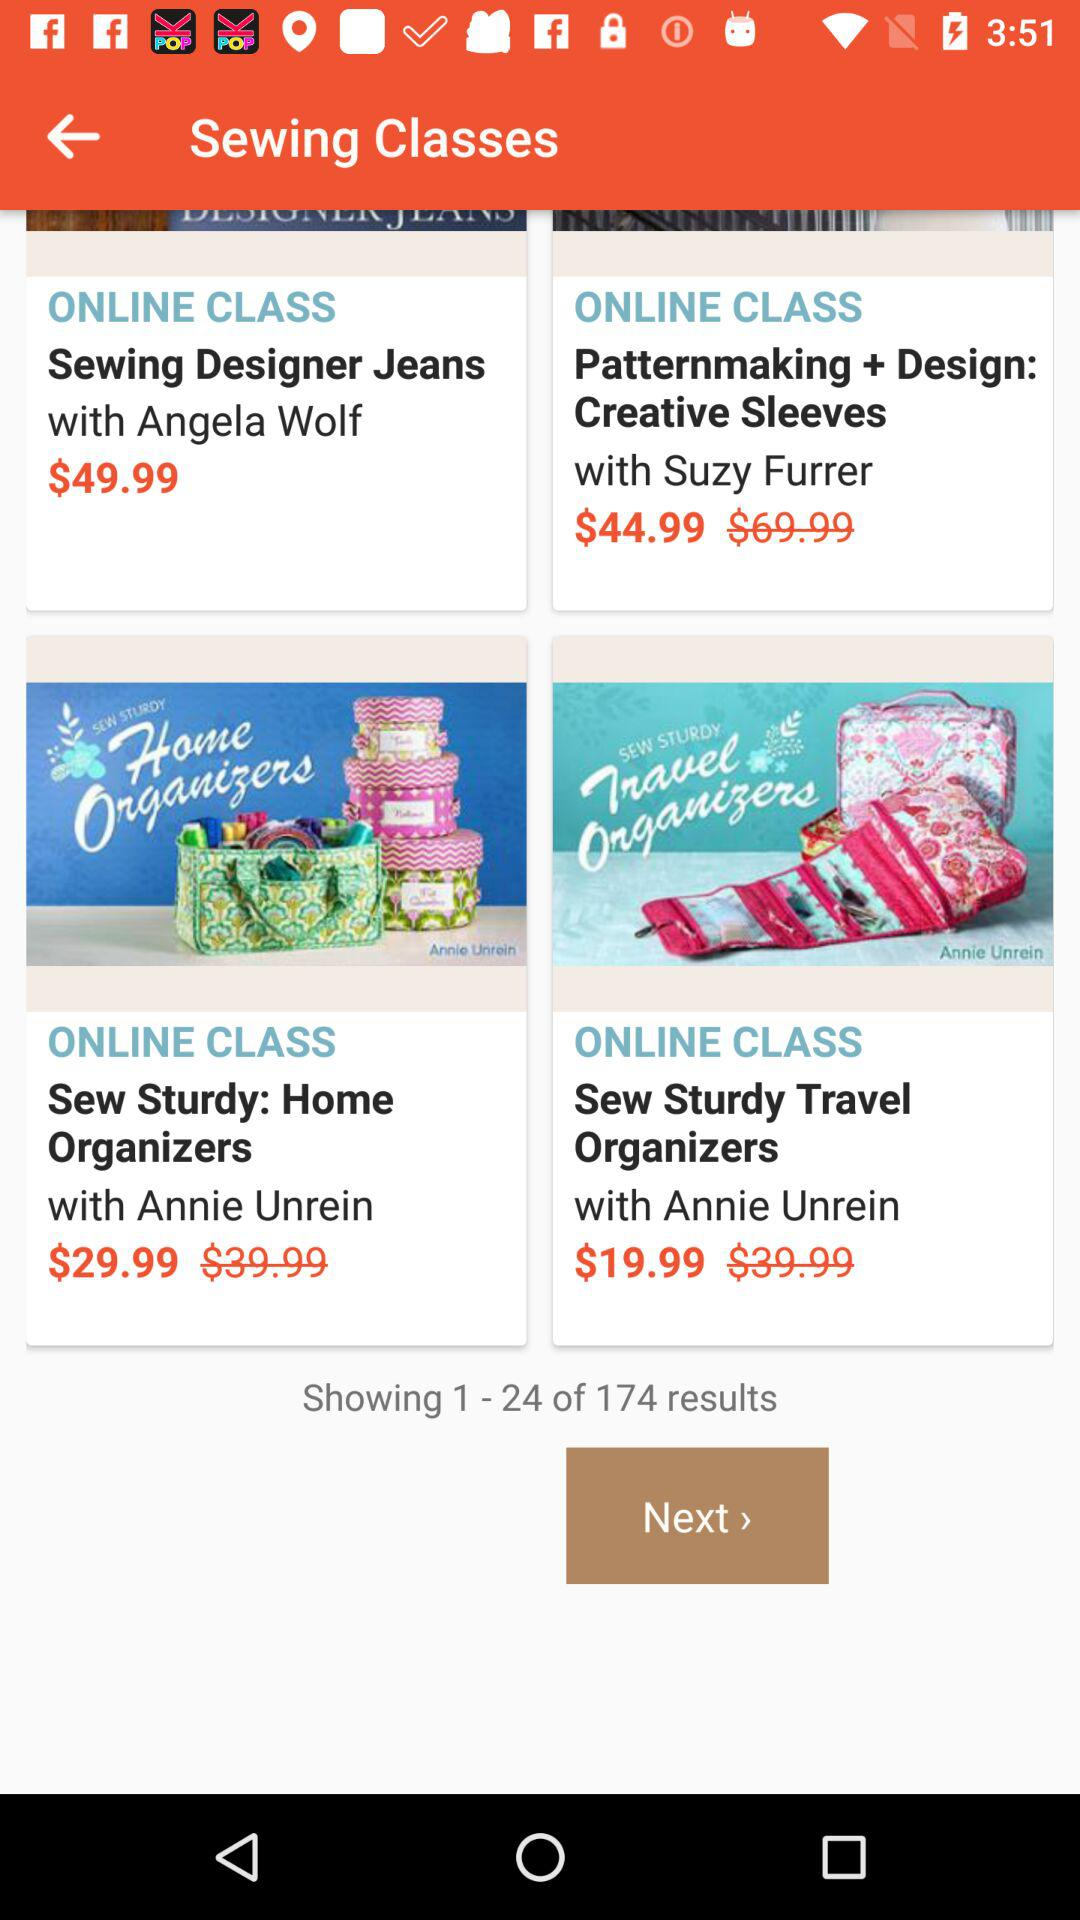How many total results are shown on the screen? There are 174 total results shown on the screen. 